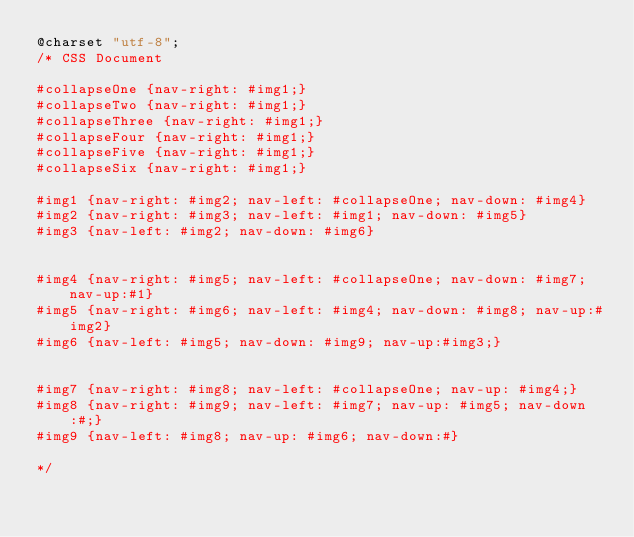<code> <loc_0><loc_0><loc_500><loc_500><_CSS_>@charset "utf-8";
/* CSS Document 

#collapseOne {nav-right: #img1;}
#collapseTwo {nav-right: #img1;}
#collapseThree {nav-right: #img1;}
#collapseFour {nav-right: #img1;}
#collapseFive {nav-right: #img1;}
#collapseSix {nav-right: #img1;}

#img1 {nav-right: #img2; nav-left: #collapseOne; nav-down: #img4}
#img2 {nav-right: #img3; nav-left: #img1; nav-down: #img5}
#img3 {nav-left: #img2; nav-down: #img6}


#img4 {nav-right: #img5; nav-left: #collapseOne; nav-down: #img7; nav-up:#1}
#img5 {nav-right: #img6; nav-left: #img4; nav-down: #img8; nav-up:#img2}
#img6 {nav-left: #img5; nav-down: #img9; nav-up:#img3;}


#img7 {nav-right: #img8; nav-left: #collapseOne; nav-up: #img4;}
#img8 {nav-right: #img9; nav-left: #img7; nav-up: #img5; nav-down:#;}
#img9 {nav-left: #img8; nav-up: #img6; nav-down:#}

*/	</code> 